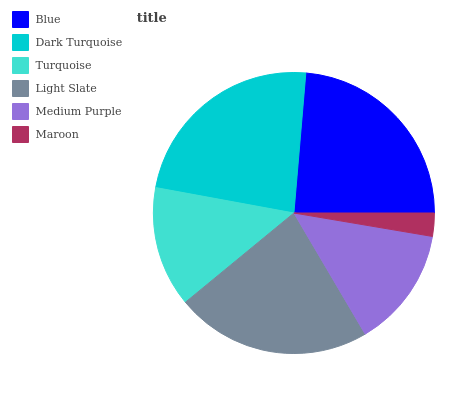Is Maroon the minimum?
Answer yes or no. Yes. Is Blue the maximum?
Answer yes or no. Yes. Is Dark Turquoise the minimum?
Answer yes or no. No. Is Dark Turquoise the maximum?
Answer yes or no. No. Is Blue greater than Dark Turquoise?
Answer yes or no. Yes. Is Dark Turquoise less than Blue?
Answer yes or no. Yes. Is Dark Turquoise greater than Blue?
Answer yes or no. No. Is Blue less than Dark Turquoise?
Answer yes or no. No. Is Light Slate the high median?
Answer yes or no. Yes. Is Medium Purple the low median?
Answer yes or no. Yes. Is Blue the high median?
Answer yes or no. No. Is Blue the low median?
Answer yes or no. No. 